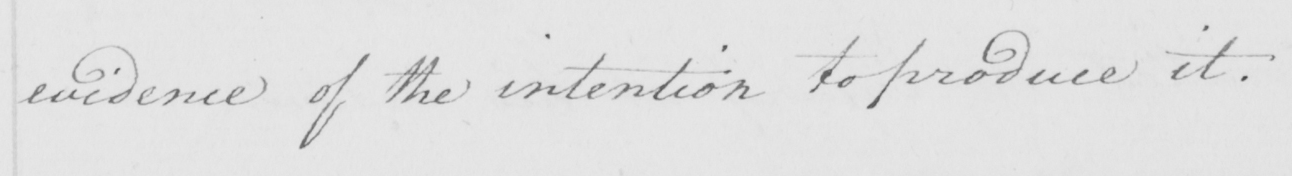What is written in this line of handwriting? evidence of the intention to produce it . 